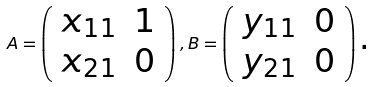Convert formula to latex. <formula><loc_0><loc_0><loc_500><loc_500>A = \left ( \begin{array} { c c } x _ { 1 1 } & 1 \\ x _ { 2 1 } & 0 \end{array} \right ) , B = \left ( \begin{array} { c c } y _ { 1 1 } & 0 \\ y _ { 2 1 } & 0 \end{array} \right ) \text {.}</formula> 